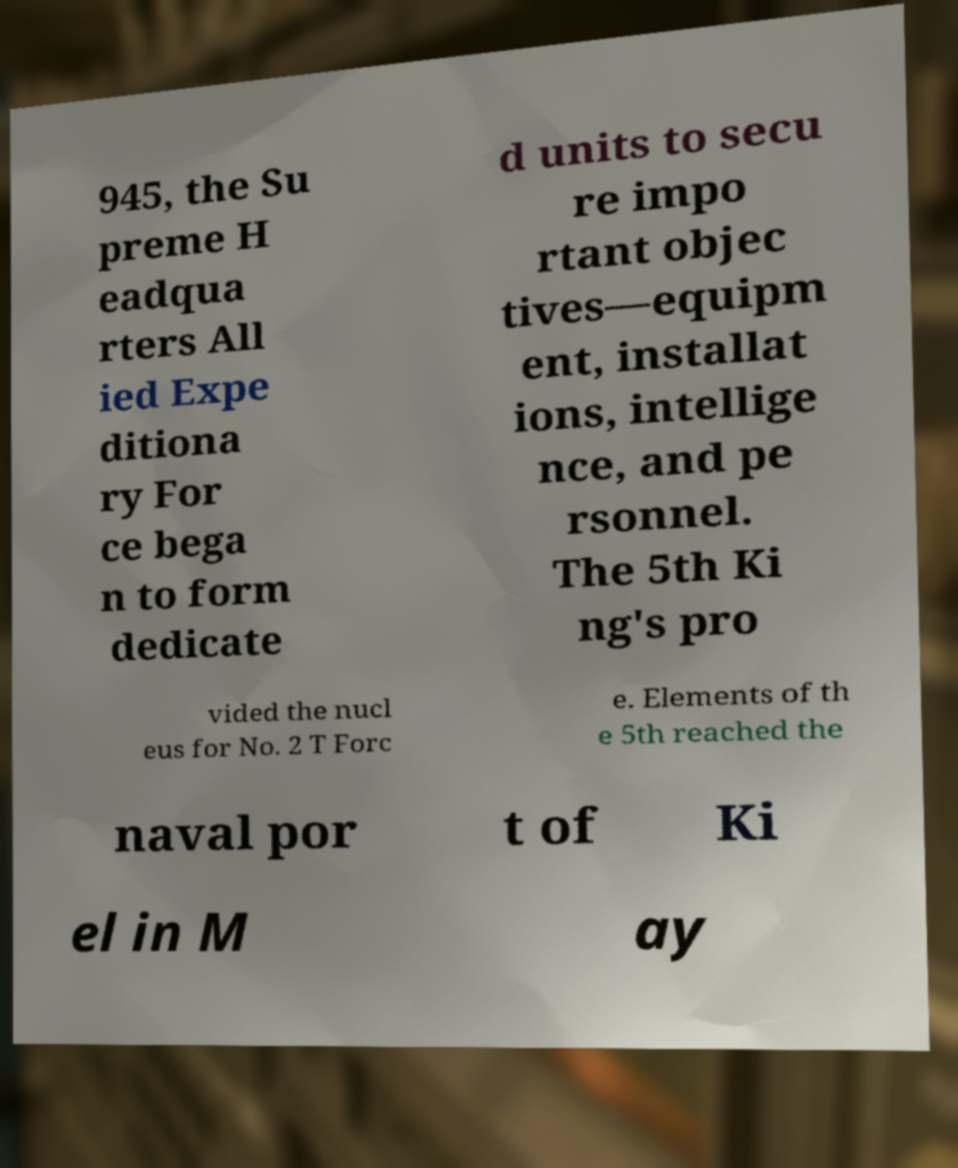Can you accurately transcribe the text from the provided image for me? 945, the Su preme H eadqua rters All ied Expe ditiona ry For ce bega n to form dedicate d units to secu re impo rtant objec tives—equipm ent, installat ions, intellige nce, and pe rsonnel. The 5th Ki ng's pro vided the nucl eus for No. 2 T Forc e. Elements of th e 5th reached the naval por t of Ki el in M ay 